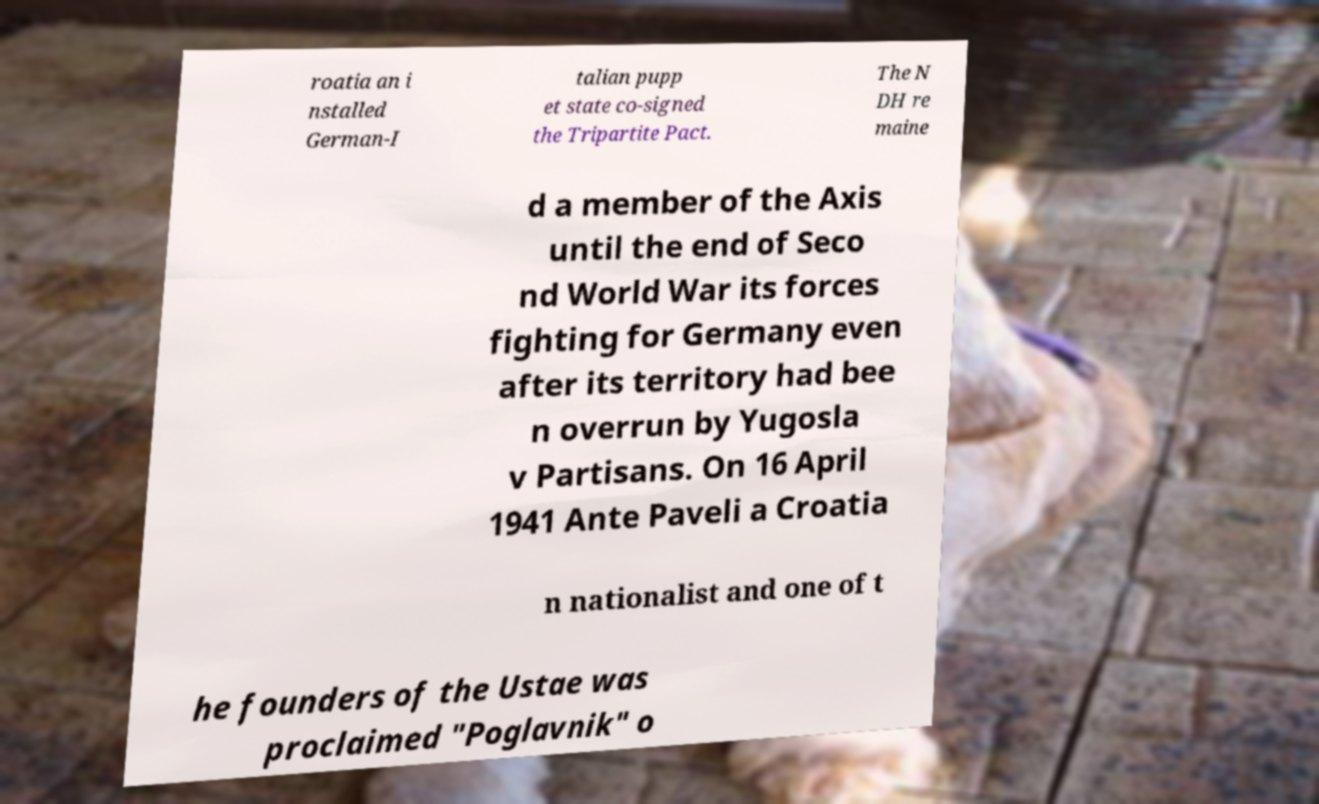Can you accurately transcribe the text from the provided image for me? roatia an i nstalled German-I talian pupp et state co-signed the Tripartite Pact. The N DH re maine d a member of the Axis until the end of Seco nd World War its forces fighting for Germany even after its territory had bee n overrun by Yugosla v Partisans. On 16 April 1941 Ante Paveli a Croatia n nationalist and one of t he founders of the Ustae was proclaimed "Poglavnik" o 